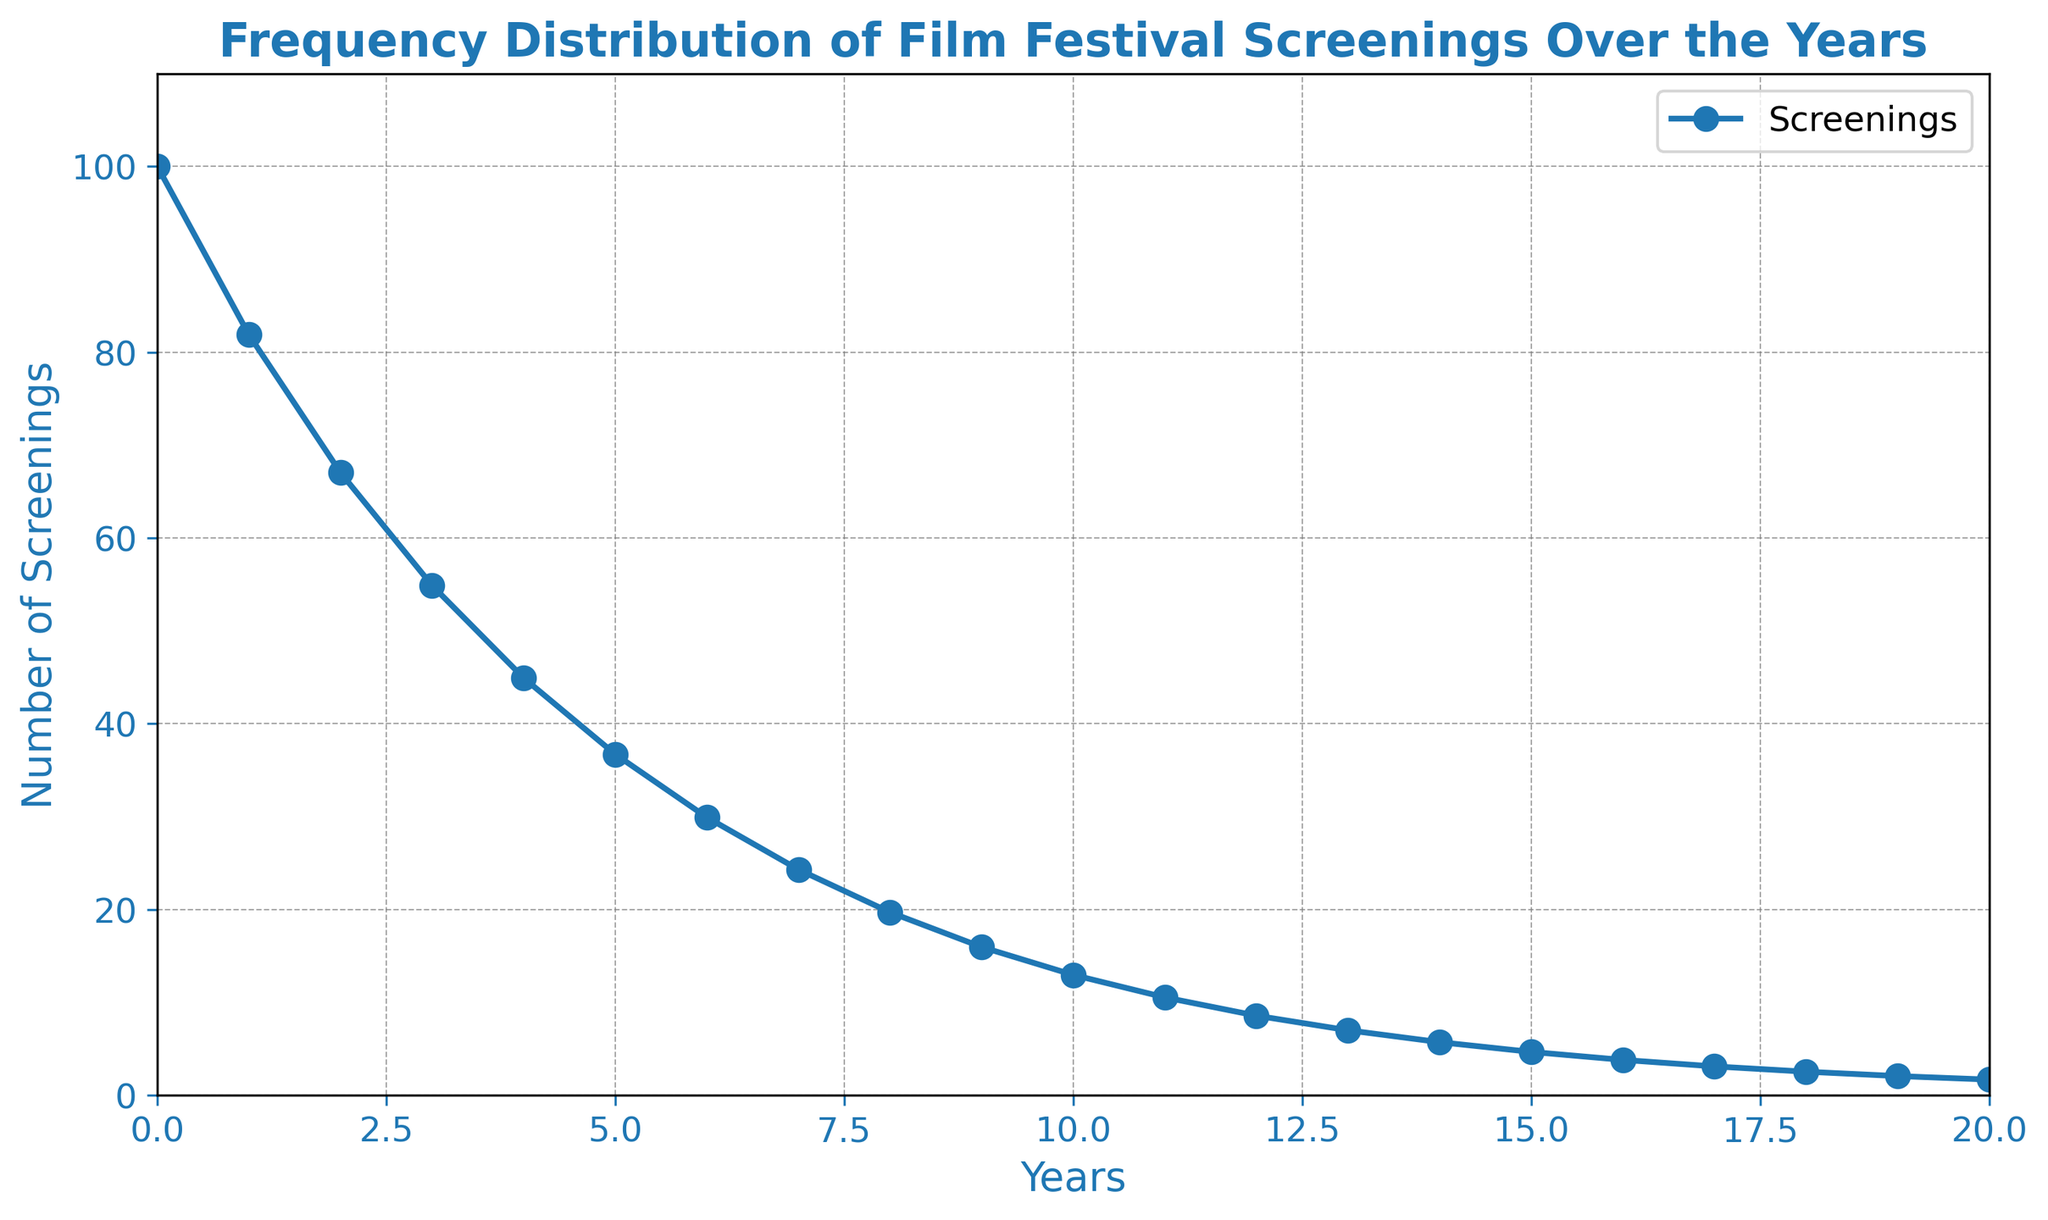What is the trend of the number of screenings over the years? The graph shows a downward trend in the number of screenings over the years. Each year, the number of screenings decreases, reflecting an exponential decay pattern.
Answer: Downward trend Approximately how many screenings occurred at year 10? From the figure, locate the point corresponding to year 10 on the x-axis, then measure its y-axis value. The point is at about 13 screenings.
Answer: 13 screenings By what approximate percentage did the screenings decrease from year 0 to year 1? Year 0 has 100 screenings and year 1 has roughly 81.87. Calculate the percentage decrease: ((100 - 81.87) / 100) * 100 ≈ 18.13%.
Answer: 18.13% Which year(s) experienced the largest relative decrease in screenings? Examine the slope steepness between consecutive years. The largest relative decrease appears between year 0 and year 1 due to the steep drop from 100 to 81.87 screenings, indicating the largest rate of decrease.
Answer: Year 0 to Year 1 What is the total number of screenings from year 0 to year 20? Sum the screening values from the figure's data points: 100 + 81.87 + 67.03 + 54.88 + 44.92 + 36.71 + 29.92 + 24.30 + 19.70 + 15.96 + 12.96 + 10.54 + 8.57 + 7.00 + 5.72 + 4.67 + 3.81 + 3.11 + 2.54 + 2.07 + 1.69 ≈ 518.97.
Answer: 518.97 screenings Compare the number of screenings at year 5 and year 15. Which year had fewer screenings? By how much? Look at the values for year 5 and year 15 from the plot: Year 5 has about 36.71 screenings, and year 15 has about 4.67 screenings. The difference is 36.71 - 4.67 ≈ 32.04 screenings.
Answer: Year 15 by 32.04 screenings Is there any year where the number of screenings approaches zero? Notice the y-values as the years progress. The screenings never quite reach zero but get very close, especially beyond year 16.
Answer: No, but close in later years What's the average number of screenings from year 10 onwards? Calculate the average by summing values from year 10 to year 20 (12.96 + 10.54 + 8.57 + 7.00 + 5.72 + 4.67 + 3.81 + 3.11 + 2.54 + 2.07 + 1.69 = 62.68) and dividing by the number of years (11): 62.68/11 ≈ 5.70.
Answer: 5.70 screenings Which color is used for both the title and axis labels of the plot? Observe the visual features of the plot. The title and axis labels are all in blue.
Answer: Blue 